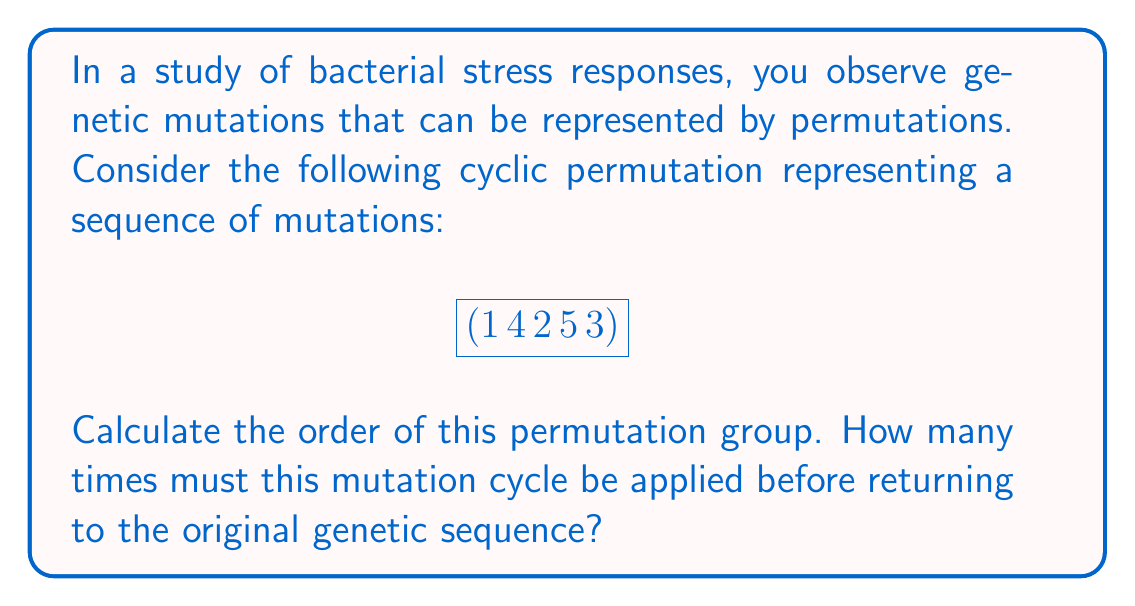Can you solve this math problem? To find the order of a permutation group, we need to determine the least common multiple (LCM) of the cycle lengths in the permutation. In this case, we have a single cycle.

Step 1: Identify the cycle length
The given permutation $(1 \, 4 \, 2 \, 5 \, 3)$ has a length of 5.

Step 2: Determine the order
For a single cycle, the order is equal to its length. Therefore, the order of this permutation group is 5.

Step 3: Interpret the result
This means that after applying the mutation cycle 5 times, the genetic sequence will return to its original state:

$$(1 \, 4 \, 2 \, 5 \, 3)^1 = (1 \, 4 \, 2 \, 5 \, 3)$$
$$(1 \, 4 \, 2 \, 5 \, 3)^2 = (1 \, 2 \, 3 \, 4 \, 5)$$
$$(1 \, 4 \, 2 \, 5 \, 3)^3 = (1 \, 5 \, 4 \, 3 \, 2)$$
$$(1 \, 4 \, 2 \, 5 \, 3)^4 = (1 \, 3 \, 5 \, 2 \, 4)$$
$$(1 \, 4 \, 2 \, 5 \, 3)^5 = (1)(2)(3)(4)(5) = \text{identity}$$

Thus, the bacterial genetic sequence will return to its original state after 5 mutation cycles.
Answer: 5 